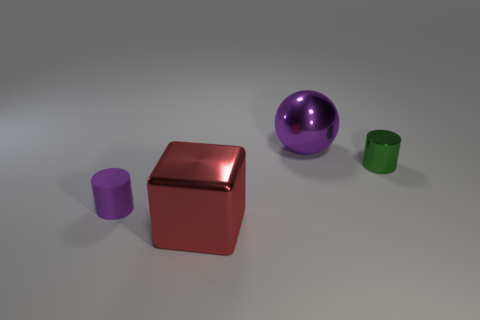What is the material of the ball that is the same color as the matte object?
Offer a very short reply. Metal. Is there any other thing that is the same shape as the small purple thing?
Your answer should be very brief. Yes. There is a large metal sphere; is it the same color as the tiny cylinder that is on the right side of the big red metal block?
Offer a terse response. No. There is a big metal thing that is in front of the purple metallic ball; what shape is it?
Your response must be concise. Cube. What number of other things are there of the same material as the big purple sphere
Offer a terse response. 2. What is the large sphere made of?
Provide a succinct answer. Metal. How many large objects are purple metallic cylinders or shiny balls?
Your response must be concise. 1. There is a big block; what number of big shiny spheres are behind it?
Ensure brevity in your answer.  1. Are there any other matte objects that have the same color as the small rubber object?
Your answer should be very brief. No. There is a purple metal thing that is the same size as the red block; what shape is it?
Make the answer very short. Sphere. 